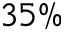Convert formula to latex. <formula><loc_0><loc_0><loc_500><loc_500>3 5 \%</formula> 